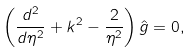<formula> <loc_0><loc_0><loc_500><loc_500>\left ( \frac { d ^ { 2 } } { d \eta ^ { 2 } } + k ^ { 2 } - \frac { 2 } { \eta ^ { 2 } } \right ) \hat { g } = 0 ,</formula> 